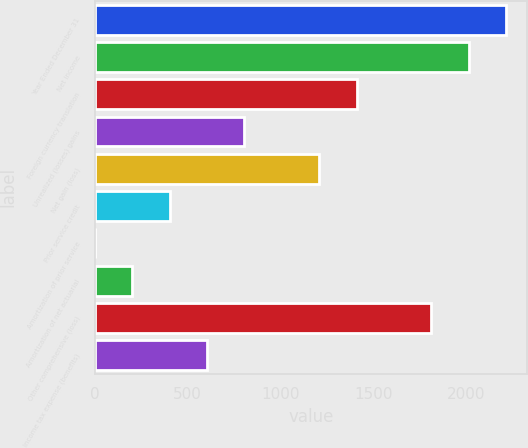Convert chart. <chart><loc_0><loc_0><loc_500><loc_500><bar_chart><fcel>Year Ended December 31<fcel>Net income<fcel>Foreign currency translation<fcel>Unrealized (losses) gains<fcel>Net gain (loss)<fcel>Prior service credit<fcel>Amortization of prior service<fcel>Amortization of net actuarial<fcel>Other comprehensive (loss)<fcel>Income tax expense (benefits)<nl><fcel>2215.3<fcel>2014<fcel>1410.1<fcel>806.2<fcel>1208.8<fcel>403.6<fcel>1<fcel>202.3<fcel>1812.7<fcel>604.9<nl></chart> 